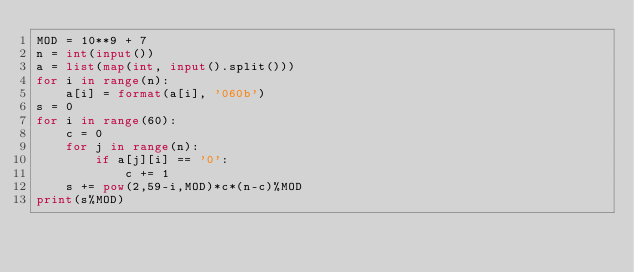Convert code to text. <code><loc_0><loc_0><loc_500><loc_500><_Python_>MOD = 10**9 + 7
n = int(input())
a = list(map(int, input().split()))
for i in range(n):
    a[i] = format(a[i], '060b')
s = 0
for i in range(60):
    c = 0
    for j in range(n):
        if a[j][i] == '0':
            c += 1
    s += pow(2,59-i,MOD)*c*(n-c)%MOD
print(s%MOD)</code> 